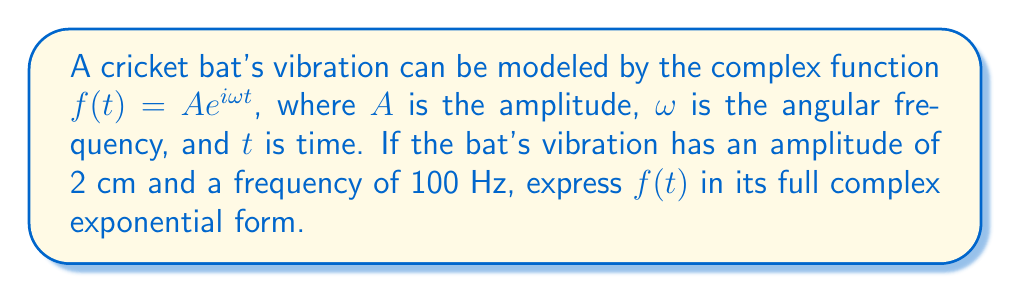What is the answer to this math problem? To express $f(t)$ in its full complex exponential form, we need to follow these steps:

1. Recall the general form of the complex function:
   $f(t) = Ae^{i\omega t}$

2. We're given the amplitude $A = 2$ cm.

3. We need to calculate $\omega$ from the given frequency:
   $\omega = 2\pi f$, where $f$ is the frequency in Hz
   $\omega = 2\pi(100) = 200\pi$ rad/s

4. Now we can substitute these values into our general form:
   $f(t) = 2e^{i(200\pi)t}$

5. To express this in its full complex exponential form, we can use Euler's formula:
   $e^{i\theta} = \cos\theta + i\sin\theta$

6. Applying this to our function:
   $f(t) = 2(\cos(200\pi t) + i\sin(200\pi t))$

This final expression represents the vibration of the cricket bat as a complex function of time, where the real part corresponds to the actual physical displacement and the imaginary part represents the phase of the vibration.
Answer: $f(t) = 2(\cos(200\pi t) + i\sin(200\pi t))$ 